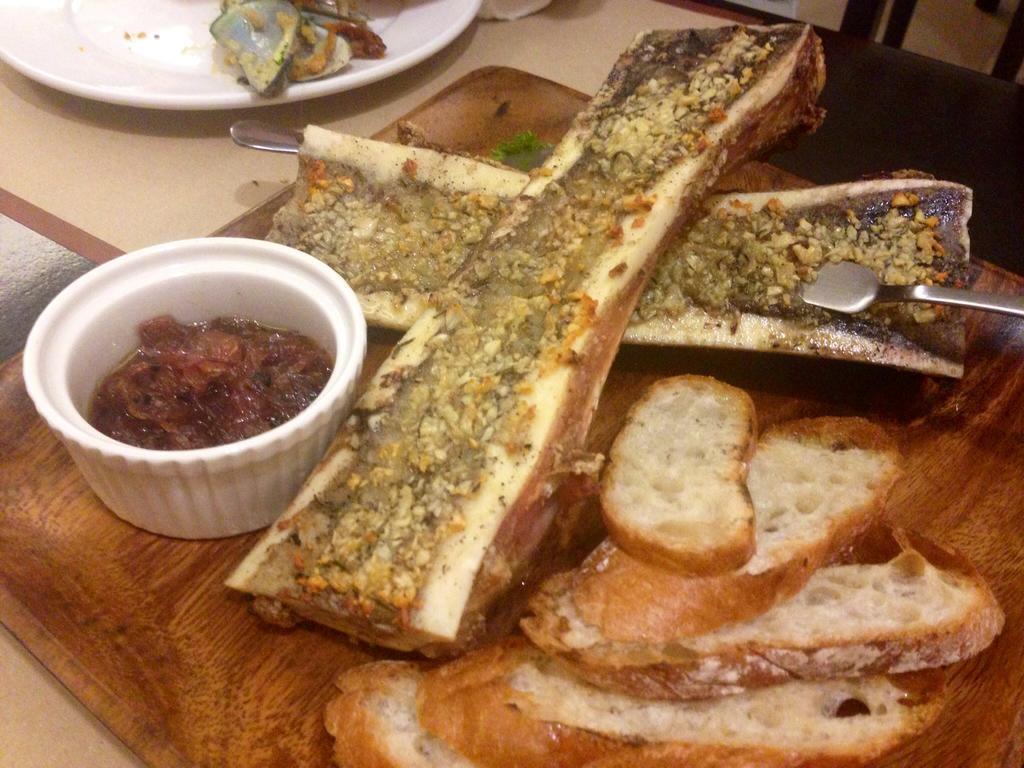Could you give a brief overview of what you see in this image? In this picture I can see some eatable items are placed in a plate, which is placed on the table, side we can see few more plates. 